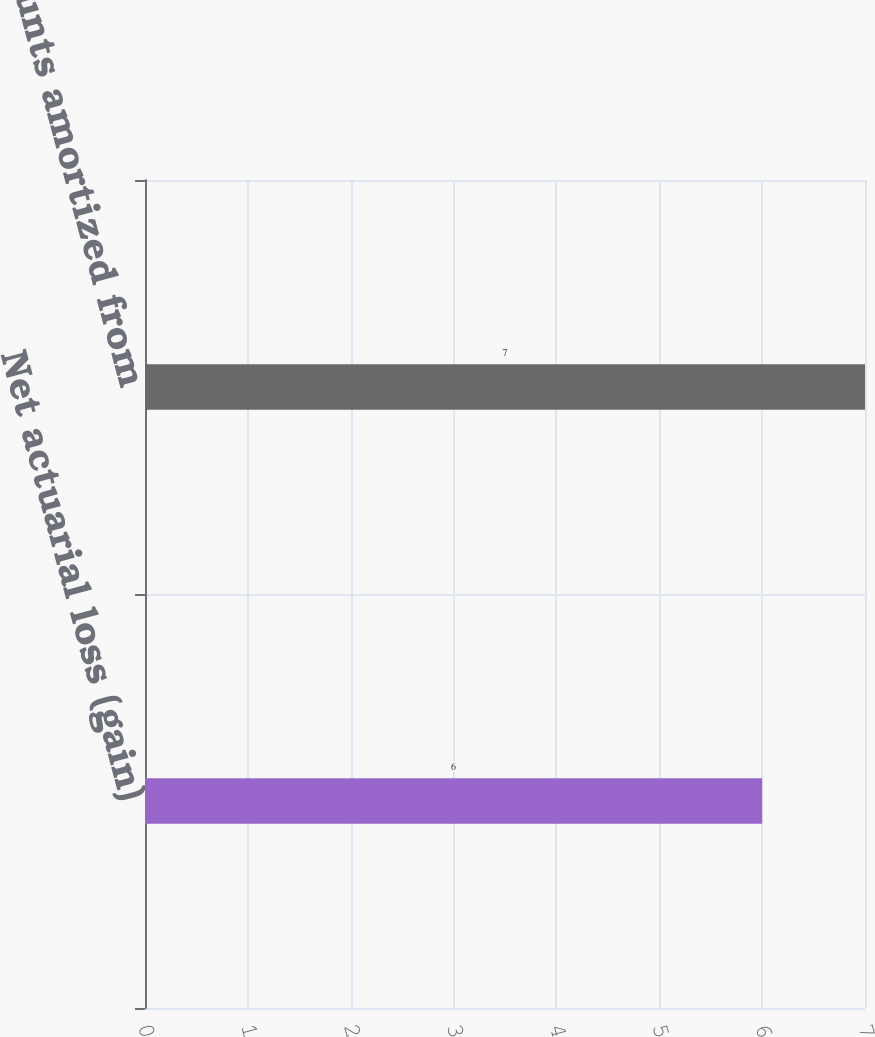Convert chart. <chart><loc_0><loc_0><loc_500><loc_500><bar_chart><fcel>Net actuarial loss (gain)<fcel>Total amounts amortized from<nl><fcel>6<fcel>7<nl></chart> 